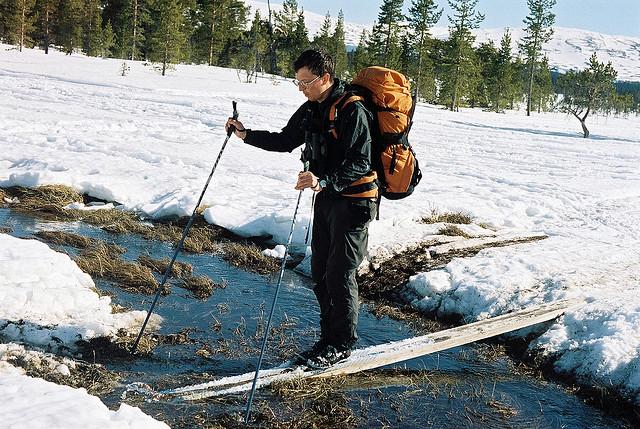Where is the skiing?
Quick response, please. Water. What kind of trees are those?
Short answer required. Pine. Is the man above water, ice or snow?
Give a very brief answer. Water. 